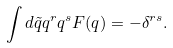Convert formula to latex. <formula><loc_0><loc_0><loc_500><loc_500>\int d \tilde { q } q ^ { r } q ^ { s } F ( q ) = - \delta ^ { r s } .</formula> 